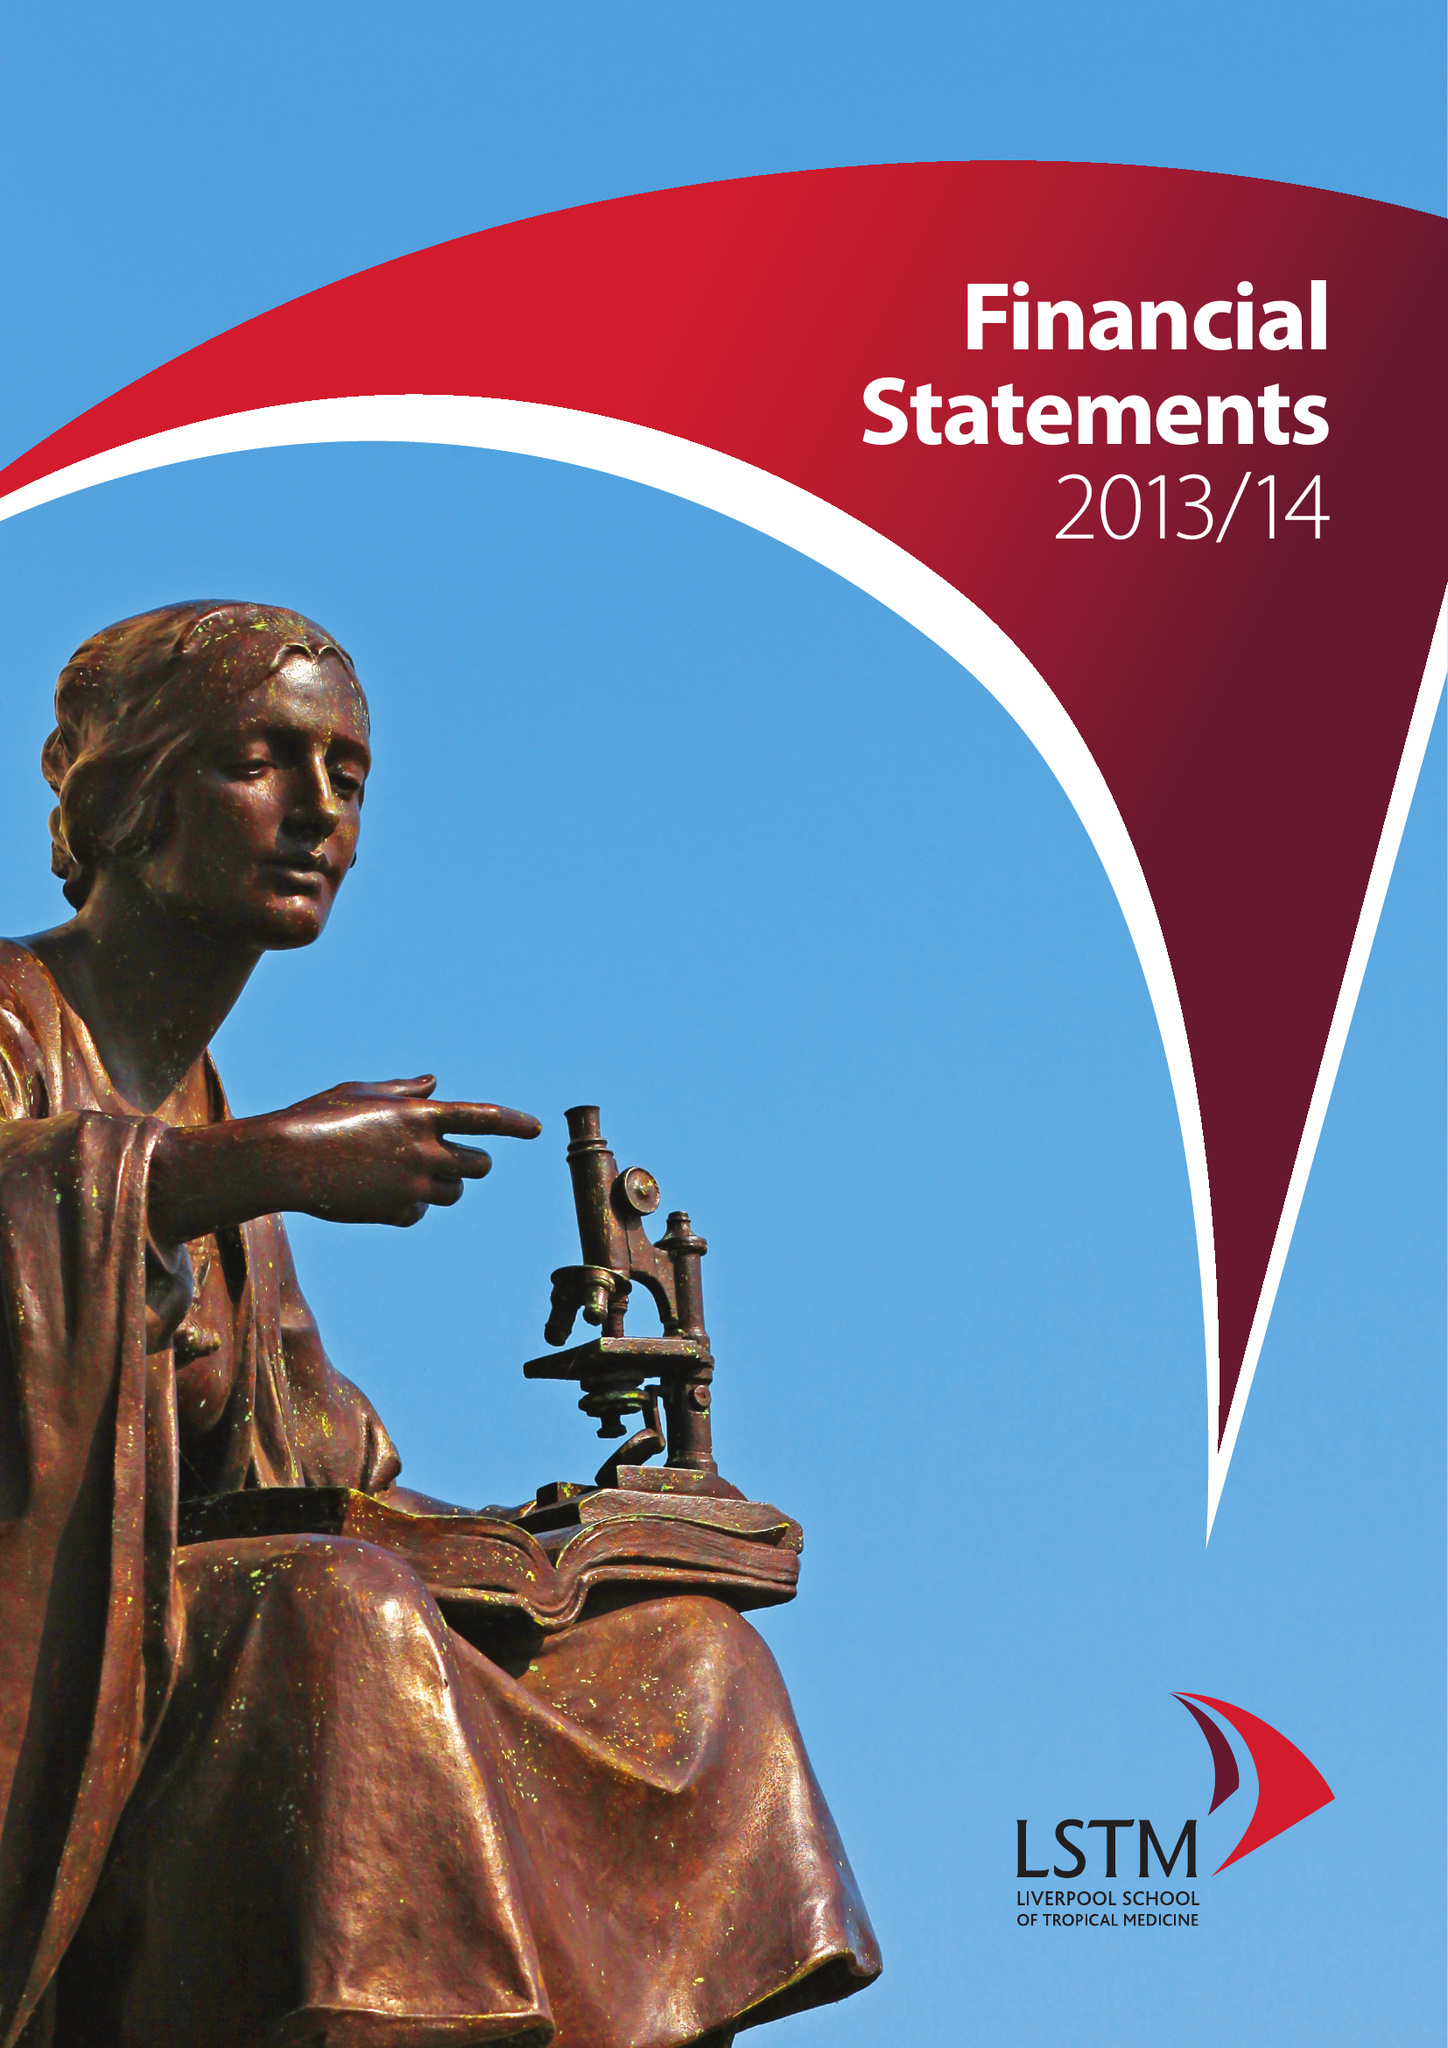What is the value for the charity_number?
Answer the question using a single word or phrase. 222655 